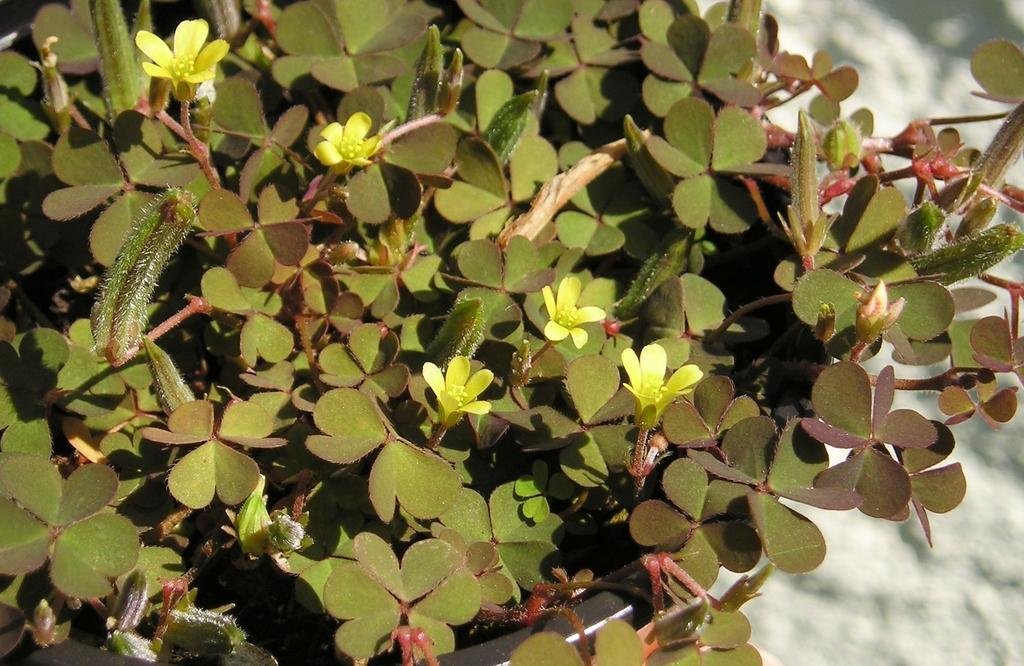What is present in the image? There is a plant in the image. What can be observed about the plant? The plant has flowers. What color are the flowers? The flowers are yellow. What is the plant placed in? There is a flower pot at the bottom of the image. What type of crime is being committed in the image? There is no crime present in the image; it features a plant with yellow flowers in a flower pot. Can you identify any railway tracks or trains in the image? There are no railway tracks or trains present in the image. 